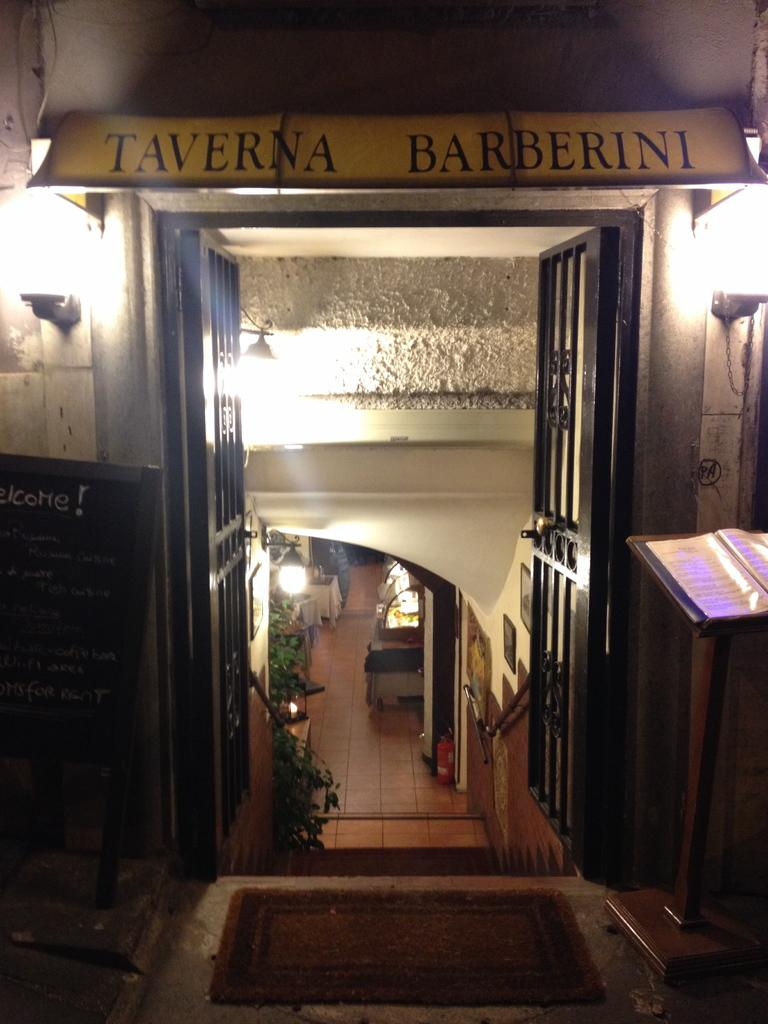What part of a house is shown in the image? The image shows the inner part of a house. What can be used to enter or exit the room in the image? There is a door visible in the image. What type of vegetation is present in the image? There are plants in green color in the image. What provides illumination in the image? There are lights visible in the image. What type of jam is being served on the table in the image? There is no table or jam present in the image. 